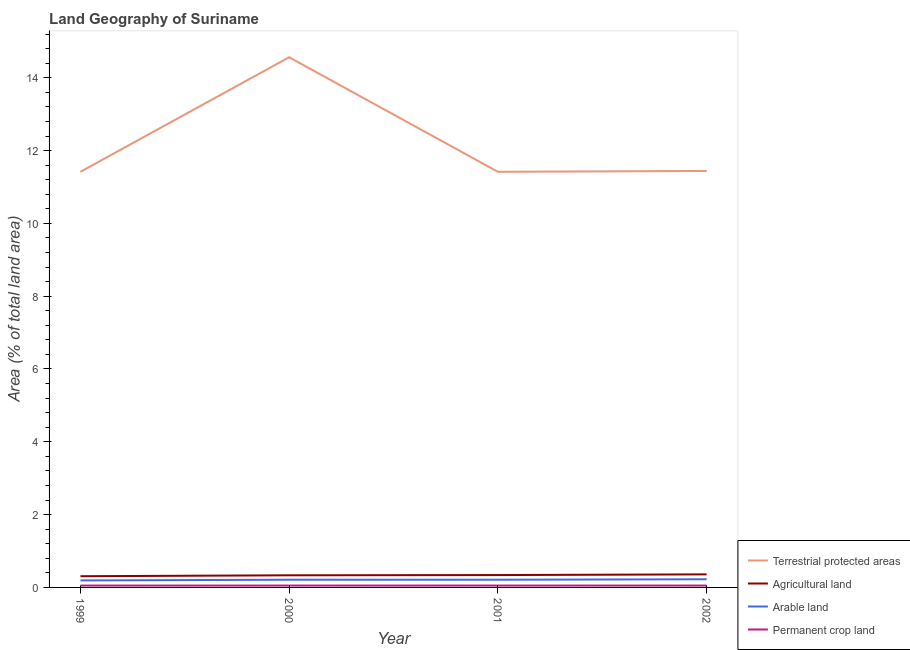How many different coloured lines are there?
Provide a succinct answer. 4. What is the percentage of area under arable land in 1999?
Your answer should be compact. 0.19. Across all years, what is the maximum percentage of area under agricultural land?
Keep it short and to the point. 0.36. Across all years, what is the minimum percentage of land under terrestrial protection?
Keep it short and to the point. 11.42. What is the total percentage of area under permanent crop land in the graph?
Ensure brevity in your answer.  0.21. What is the difference between the percentage of land under terrestrial protection in 1999 and that in 2001?
Your answer should be very brief. -8.781929849988046e-8. What is the difference between the percentage of land under terrestrial protection in 2000 and the percentage of area under agricultural land in 1999?
Ensure brevity in your answer.  14.26. What is the average percentage of land under terrestrial protection per year?
Give a very brief answer. 12.21. In the year 1999, what is the difference between the percentage of area under arable land and percentage of land under terrestrial protection?
Your answer should be compact. -11.22. What is the difference between the highest and the second highest percentage of area under arable land?
Provide a short and direct response. 0.01. What is the difference between the highest and the lowest percentage of land under terrestrial protection?
Offer a very short reply. 3.15. Is the sum of the percentage of area under permanent crop land in 1999 and 2000 greater than the maximum percentage of land under terrestrial protection across all years?
Ensure brevity in your answer.  No. Is it the case that in every year, the sum of the percentage of area under agricultural land and percentage of land under terrestrial protection is greater than the sum of percentage of area under arable land and percentage of area under permanent crop land?
Give a very brief answer. Yes. Is the percentage of area under arable land strictly less than the percentage of land under terrestrial protection over the years?
Your answer should be compact. Yes. How many lines are there?
Offer a terse response. 4. How many years are there in the graph?
Your answer should be very brief. 4. What is the difference between two consecutive major ticks on the Y-axis?
Your answer should be compact. 2. Are the values on the major ticks of Y-axis written in scientific E-notation?
Keep it short and to the point. No. Does the graph contain grids?
Offer a very short reply. No. How many legend labels are there?
Your answer should be very brief. 4. What is the title of the graph?
Your answer should be compact. Land Geography of Suriname. What is the label or title of the Y-axis?
Provide a short and direct response. Area (% of total land area). What is the Area (% of total land area) in Terrestrial protected areas in 1999?
Your answer should be very brief. 11.42. What is the Area (% of total land area) in Agricultural land in 1999?
Provide a short and direct response. 0.31. What is the Area (% of total land area) of Arable land in 1999?
Offer a very short reply. 0.19. What is the Area (% of total land area) of Permanent crop land in 1999?
Your response must be concise. 0.05. What is the Area (% of total land area) in Terrestrial protected areas in 2000?
Make the answer very short. 14.56. What is the Area (% of total land area) of Agricultural land in 2000?
Keep it short and to the point. 0.33. What is the Area (% of total land area) in Arable land in 2000?
Offer a terse response. 0.21. What is the Area (% of total land area) in Permanent crop land in 2000?
Offer a terse response. 0.05. What is the Area (% of total land area) of Terrestrial protected areas in 2001?
Provide a short and direct response. 11.42. What is the Area (% of total land area) in Agricultural land in 2001?
Make the answer very short. 0.34. What is the Area (% of total land area) of Arable land in 2001?
Give a very brief answer. 0.21. What is the Area (% of total land area) of Permanent crop land in 2001?
Your response must be concise. 0.05. What is the Area (% of total land area) in Terrestrial protected areas in 2002?
Provide a short and direct response. 11.44. What is the Area (% of total land area) in Agricultural land in 2002?
Provide a short and direct response. 0.36. What is the Area (% of total land area) of Arable land in 2002?
Keep it short and to the point. 0.22. What is the Area (% of total land area) in Permanent crop land in 2002?
Keep it short and to the point. 0.05. Across all years, what is the maximum Area (% of total land area) of Terrestrial protected areas?
Provide a succinct answer. 14.56. Across all years, what is the maximum Area (% of total land area) in Agricultural land?
Keep it short and to the point. 0.36. Across all years, what is the maximum Area (% of total land area) of Arable land?
Your response must be concise. 0.22. Across all years, what is the maximum Area (% of total land area) of Permanent crop land?
Keep it short and to the point. 0.05. Across all years, what is the minimum Area (% of total land area) of Terrestrial protected areas?
Make the answer very short. 11.42. Across all years, what is the minimum Area (% of total land area) of Agricultural land?
Your answer should be very brief. 0.31. Across all years, what is the minimum Area (% of total land area) of Arable land?
Offer a very short reply. 0.19. Across all years, what is the minimum Area (% of total land area) in Permanent crop land?
Offer a terse response. 0.05. What is the total Area (% of total land area) in Terrestrial protected areas in the graph?
Your answer should be very brief. 48.84. What is the total Area (% of total land area) of Agricultural land in the graph?
Provide a short and direct response. 1.34. What is the total Area (% of total land area) in Arable land in the graph?
Give a very brief answer. 0.84. What is the total Area (% of total land area) of Permanent crop land in the graph?
Make the answer very short. 0.21. What is the difference between the Area (% of total land area) in Terrestrial protected areas in 1999 and that in 2000?
Provide a short and direct response. -3.15. What is the difference between the Area (% of total land area) in Agricultural land in 1999 and that in 2000?
Keep it short and to the point. -0.03. What is the difference between the Area (% of total land area) of Arable land in 1999 and that in 2000?
Offer a terse response. -0.02. What is the difference between the Area (% of total land area) in Permanent crop land in 1999 and that in 2000?
Offer a very short reply. 0. What is the difference between the Area (% of total land area) of Agricultural land in 1999 and that in 2001?
Your answer should be compact. -0.03. What is the difference between the Area (% of total land area) of Arable land in 1999 and that in 2001?
Give a very brief answer. -0.02. What is the difference between the Area (% of total land area) of Terrestrial protected areas in 1999 and that in 2002?
Your answer should be very brief. -0.02. What is the difference between the Area (% of total land area) of Agricultural land in 1999 and that in 2002?
Offer a terse response. -0.05. What is the difference between the Area (% of total land area) of Arable land in 1999 and that in 2002?
Provide a short and direct response. -0.03. What is the difference between the Area (% of total land area) in Permanent crop land in 1999 and that in 2002?
Keep it short and to the point. 0. What is the difference between the Area (% of total land area) in Terrestrial protected areas in 2000 and that in 2001?
Keep it short and to the point. 3.15. What is the difference between the Area (% of total land area) of Agricultural land in 2000 and that in 2001?
Keep it short and to the point. -0.01. What is the difference between the Area (% of total land area) of Arable land in 2000 and that in 2001?
Make the answer very short. 0. What is the difference between the Area (% of total land area) of Terrestrial protected areas in 2000 and that in 2002?
Your response must be concise. 3.12. What is the difference between the Area (% of total land area) of Agricultural land in 2000 and that in 2002?
Give a very brief answer. -0.03. What is the difference between the Area (% of total land area) of Arable land in 2000 and that in 2002?
Keep it short and to the point. -0.01. What is the difference between the Area (% of total land area) of Terrestrial protected areas in 2001 and that in 2002?
Give a very brief answer. -0.02. What is the difference between the Area (% of total land area) of Agricultural land in 2001 and that in 2002?
Make the answer very short. -0.02. What is the difference between the Area (% of total land area) in Arable land in 2001 and that in 2002?
Give a very brief answer. -0.01. What is the difference between the Area (% of total land area) of Terrestrial protected areas in 1999 and the Area (% of total land area) of Agricultural land in 2000?
Your response must be concise. 11.08. What is the difference between the Area (% of total land area) in Terrestrial protected areas in 1999 and the Area (% of total land area) in Arable land in 2000?
Your response must be concise. 11.21. What is the difference between the Area (% of total land area) in Terrestrial protected areas in 1999 and the Area (% of total land area) in Permanent crop land in 2000?
Your answer should be compact. 11.37. What is the difference between the Area (% of total land area) of Agricultural land in 1999 and the Area (% of total land area) of Arable land in 2000?
Provide a succinct answer. 0.1. What is the difference between the Area (% of total land area) of Agricultural land in 1999 and the Area (% of total land area) of Permanent crop land in 2000?
Offer a terse response. 0.26. What is the difference between the Area (% of total land area) of Arable land in 1999 and the Area (% of total land area) of Permanent crop land in 2000?
Ensure brevity in your answer.  0.14. What is the difference between the Area (% of total land area) of Terrestrial protected areas in 1999 and the Area (% of total land area) of Agricultural land in 2001?
Your answer should be very brief. 11.08. What is the difference between the Area (% of total land area) of Terrestrial protected areas in 1999 and the Area (% of total land area) of Arable land in 2001?
Provide a short and direct response. 11.21. What is the difference between the Area (% of total land area) in Terrestrial protected areas in 1999 and the Area (% of total land area) in Permanent crop land in 2001?
Ensure brevity in your answer.  11.37. What is the difference between the Area (% of total land area) of Agricultural land in 1999 and the Area (% of total land area) of Arable land in 2001?
Keep it short and to the point. 0.1. What is the difference between the Area (% of total land area) of Agricultural land in 1999 and the Area (% of total land area) of Permanent crop land in 2001?
Provide a short and direct response. 0.26. What is the difference between the Area (% of total land area) in Arable land in 1999 and the Area (% of total land area) in Permanent crop land in 2001?
Provide a succinct answer. 0.14. What is the difference between the Area (% of total land area) of Terrestrial protected areas in 1999 and the Area (% of total land area) of Agricultural land in 2002?
Your answer should be very brief. 11.06. What is the difference between the Area (% of total land area) of Terrestrial protected areas in 1999 and the Area (% of total land area) of Arable land in 2002?
Give a very brief answer. 11.19. What is the difference between the Area (% of total land area) of Terrestrial protected areas in 1999 and the Area (% of total land area) of Permanent crop land in 2002?
Keep it short and to the point. 11.37. What is the difference between the Area (% of total land area) of Agricultural land in 1999 and the Area (% of total land area) of Arable land in 2002?
Give a very brief answer. 0.08. What is the difference between the Area (% of total land area) of Agricultural land in 1999 and the Area (% of total land area) of Permanent crop land in 2002?
Your response must be concise. 0.26. What is the difference between the Area (% of total land area) in Arable land in 1999 and the Area (% of total land area) in Permanent crop land in 2002?
Offer a very short reply. 0.14. What is the difference between the Area (% of total land area) of Terrestrial protected areas in 2000 and the Area (% of total land area) of Agricultural land in 2001?
Your answer should be very brief. 14.22. What is the difference between the Area (% of total land area) of Terrestrial protected areas in 2000 and the Area (% of total land area) of Arable land in 2001?
Provide a succinct answer. 14.35. What is the difference between the Area (% of total land area) of Terrestrial protected areas in 2000 and the Area (% of total land area) of Permanent crop land in 2001?
Your answer should be compact. 14.51. What is the difference between the Area (% of total land area) of Agricultural land in 2000 and the Area (% of total land area) of Arable land in 2001?
Ensure brevity in your answer.  0.12. What is the difference between the Area (% of total land area) of Agricultural land in 2000 and the Area (% of total land area) of Permanent crop land in 2001?
Offer a very short reply. 0.28. What is the difference between the Area (% of total land area) in Arable land in 2000 and the Area (% of total land area) in Permanent crop land in 2001?
Offer a very short reply. 0.16. What is the difference between the Area (% of total land area) of Terrestrial protected areas in 2000 and the Area (% of total land area) of Agricultural land in 2002?
Offer a terse response. 14.2. What is the difference between the Area (% of total land area) of Terrestrial protected areas in 2000 and the Area (% of total land area) of Arable land in 2002?
Provide a succinct answer. 14.34. What is the difference between the Area (% of total land area) in Terrestrial protected areas in 2000 and the Area (% of total land area) in Permanent crop land in 2002?
Your answer should be very brief. 14.51. What is the difference between the Area (% of total land area) in Agricultural land in 2000 and the Area (% of total land area) in Arable land in 2002?
Your answer should be very brief. 0.11. What is the difference between the Area (% of total land area) in Agricultural land in 2000 and the Area (% of total land area) in Permanent crop land in 2002?
Make the answer very short. 0.28. What is the difference between the Area (% of total land area) in Arable land in 2000 and the Area (% of total land area) in Permanent crop land in 2002?
Offer a terse response. 0.16. What is the difference between the Area (% of total land area) in Terrestrial protected areas in 2001 and the Area (% of total land area) in Agricultural land in 2002?
Provide a succinct answer. 11.06. What is the difference between the Area (% of total land area) of Terrestrial protected areas in 2001 and the Area (% of total land area) of Arable land in 2002?
Provide a succinct answer. 11.19. What is the difference between the Area (% of total land area) of Terrestrial protected areas in 2001 and the Area (% of total land area) of Permanent crop land in 2002?
Offer a terse response. 11.37. What is the difference between the Area (% of total land area) of Agricultural land in 2001 and the Area (% of total land area) of Arable land in 2002?
Keep it short and to the point. 0.12. What is the difference between the Area (% of total land area) of Agricultural land in 2001 and the Area (% of total land area) of Permanent crop land in 2002?
Your answer should be very brief. 0.29. What is the difference between the Area (% of total land area) of Arable land in 2001 and the Area (% of total land area) of Permanent crop land in 2002?
Give a very brief answer. 0.16. What is the average Area (% of total land area) of Terrestrial protected areas per year?
Your response must be concise. 12.21. What is the average Area (% of total land area) of Agricultural land per year?
Ensure brevity in your answer.  0.33. What is the average Area (% of total land area) in Arable land per year?
Provide a succinct answer. 0.21. What is the average Area (% of total land area) in Permanent crop land per year?
Your answer should be compact. 0.05. In the year 1999, what is the difference between the Area (% of total land area) of Terrestrial protected areas and Area (% of total land area) of Agricultural land?
Your answer should be compact. 11.11. In the year 1999, what is the difference between the Area (% of total land area) in Terrestrial protected areas and Area (% of total land area) in Arable land?
Your answer should be compact. 11.22. In the year 1999, what is the difference between the Area (% of total land area) in Terrestrial protected areas and Area (% of total land area) in Permanent crop land?
Provide a short and direct response. 11.37. In the year 1999, what is the difference between the Area (% of total land area) of Agricultural land and Area (% of total land area) of Arable land?
Offer a terse response. 0.12. In the year 1999, what is the difference between the Area (% of total land area) in Agricultural land and Area (% of total land area) in Permanent crop land?
Provide a succinct answer. 0.26. In the year 1999, what is the difference between the Area (% of total land area) in Arable land and Area (% of total land area) in Permanent crop land?
Your response must be concise. 0.14. In the year 2000, what is the difference between the Area (% of total land area) of Terrestrial protected areas and Area (% of total land area) of Agricultural land?
Your answer should be very brief. 14.23. In the year 2000, what is the difference between the Area (% of total land area) in Terrestrial protected areas and Area (% of total land area) in Arable land?
Make the answer very short. 14.35. In the year 2000, what is the difference between the Area (% of total land area) of Terrestrial protected areas and Area (% of total land area) of Permanent crop land?
Your answer should be compact. 14.51. In the year 2000, what is the difference between the Area (% of total land area) in Agricultural land and Area (% of total land area) in Arable land?
Give a very brief answer. 0.12. In the year 2000, what is the difference between the Area (% of total land area) in Agricultural land and Area (% of total land area) in Permanent crop land?
Your answer should be very brief. 0.28. In the year 2000, what is the difference between the Area (% of total land area) in Arable land and Area (% of total land area) in Permanent crop land?
Ensure brevity in your answer.  0.16. In the year 2001, what is the difference between the Area (% of total land area) of Terrestrial protected areas and Area (% of total land area) of Agricultural land?
Offer a very short reply. 11.08. In the year 2001, what is the difference between the Area (% of total land area) of Terrestrial protected areas and Area (% of total land area) of Arable land?
Make the answer very short. 11.21. In the year 2001, what is the difference between the Area (% of total land area) in Terrestrial protected areas and Area (% of total land area) in Permanent crop land?
Give a very brief answer. 11.37. In the year 2001, what is the difference between the Area (% of total land area) of Agricultural land and Area (% of total land area) of Arable land?
Provide a succinct answer. 0.13. In the year 2001, what is the difference between the Area (% of total land area) of Agricultural land and Area (% of total land area) of Permanent crop land?
Your response must be concise. 0.29. In the year 2001, what is the difference between the Area (% of total land area) in Arable land and Area (% of total land area) in Permanent crop land?
Ensure brevity in your answer.  0.16. In the year 2002, what is the difference between the Area (% of total land area) of Terrestrial protected areas and Area (% of total land area) of Agricultural land?
Your answer should be very brief. 11.08. In the year 2002, what is the difference between the Area (% of total land area) of Terrestrial protected areas and Area (% of total land area) of Arable land?
Keep it short and to the point. 11.22. In the year 2002, what is the difference between the Area (% of total land area) of Terrestrial protected areas and Area (% of total land area) of Permanent crop land?
Your answer should be compact. 11.39. In the year 2002, what is the difference between the Area (% of total land area) of Agricultural land and Area (% of total land area) of Arable land?
Keep it short and to the point. 0.13. In the year 2002, what is the difference between the Area (% of total land area) of Agricultural land and Area (% of total land area) of Permanent crop land?
Give a very brief answer. 0.31. In the year 2002, what is the difference between the Area (% of total land area) of Arable land and Area (% of total land area) of Permanent crop land?
Offer a terse response. 0.17. What is the ratio of the Area (% of total land area) in Terrestrial protected areas in 1999 to that in 2000?
Offer a very short reply. 0.78. What is the ratio of the Area (% of total land area) of Arable land in 1999 to that in 2000?
Provide a short and direct response. 0.91. What is the ratio of the Area (% of total land area) of Agricultural land in 1999 to that in 2001?
Provide a short and direct response. 0.91. What is the ratio of the Area (% of total land area) of Permanent crop land in 1999 to that in 2001?
Offer a terse response. 1. What is the ratio of the Area (% of total land area) of Terrestrial protected areas in 1999 to that in 2002?
Ensure brevity in your answer.  1. What is the ratio of the Area (% of total land area) of Agricultural land in 1999 to that in 2002?
Ensure brevity in your answer.  0.86. What is the ratio of the Area (% of total land area) in Arable land in 1999 to that in 2002?
Your answer should be very brief. 0.86. What is the ratio of the Area (% of total land area) in Terrestrial protected areas in 2000 to that in 2001?
Your response must be concise. 1.28. What is the ratio of the Area (% of total land area) in Agricultural land in 2000 to that in 2001?
Offer a terse response. 0.98. What is the ratio of the Area (% of total land area) in Permanent crop land in 2000 to that in 2001?
Ensure brevity in your answer.  1. What is the ratio of the Area (% of total land area) of Terrestrial protected areas in 2000 to that in 2002?
Provide a short and direct response. 1.27. What is the ratio of the Area (% of total land area) of Arable land in 2000 to that in 2002?
Offer a terse response. 0.94. What is the ratio of the Area (% of total land area) of Permanent crop land in 2000 to that in 2002?
Provide a succinct answer. 1. What is the ratio of the Area (% of total land area) of Agricultural land in 2001 to that in 2002?
Provide a short and direct response. 0.95. What is the ratio of the Area (% of total land area) of Arable land in 2001 to that in 2002?
Your answer should be compact. 0.94. What is the difference between the highest and the second highest Area (% of total land area) in Terrestrial protected areas?
Provide a succinct answer. 3.12. What is the difference between the highest and the second highest Area (% of total land area) of Agricultural land?
Your response must be concise. 0.02. What is the difference between the highest and the second highest Area (% of total land area) of Arable land?
Provide a succinct answer. 0.01. What is the difference between the highest and the lowest Area (% of total land area) in Terrestrial protected areas?
Offer a very short reply. 3.15. What is the difference between the highest and the lowest Area (% of total land area) in Agricultural land?
Offer a terse response. 0.05. What is the difference between the highest and the lowest Area (% of total land area) in Arable land?
Your response must be concise. 0.03. What is the difference between the highest and the lowest Area (% of total land area) in Permanent crop land?
Offer a terse response. 0. 